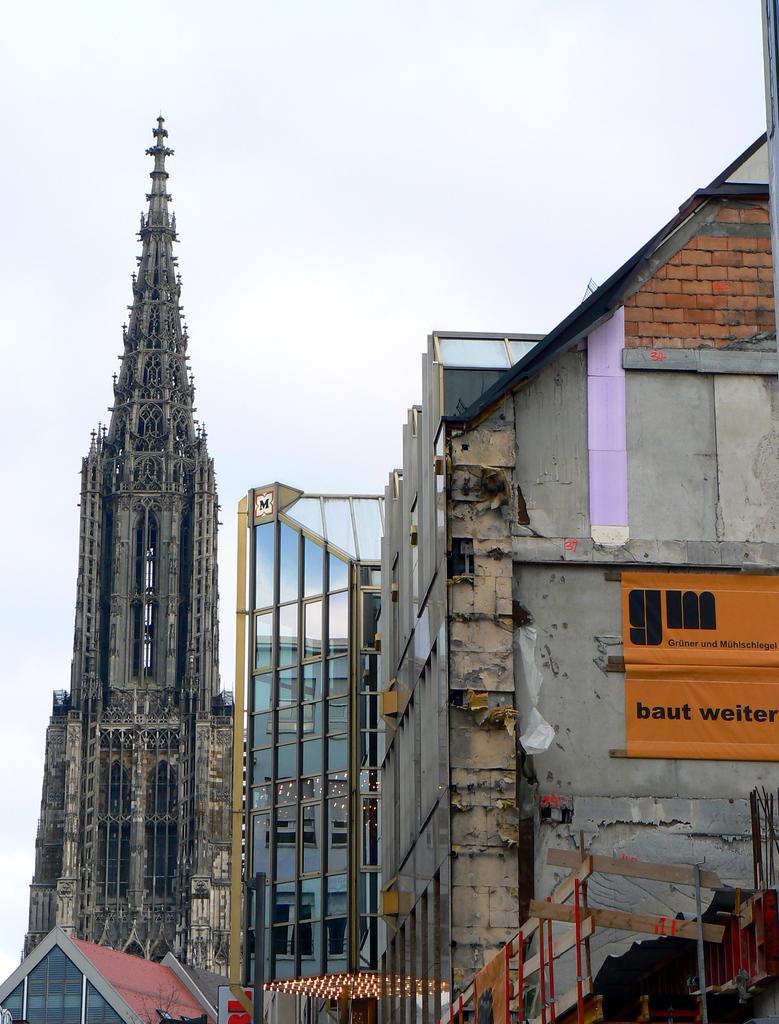In one or two sentences, can you explain what this image depicts? This image consists of buildings along with tower. At the top, there is sky. On the right, we can see a banner on the building. 